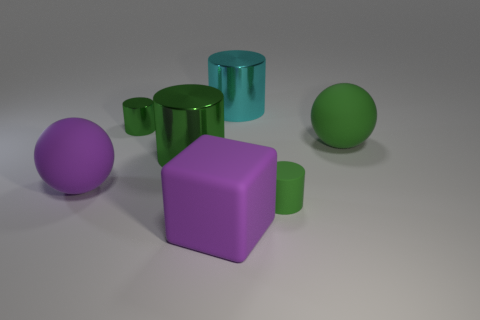Are there the same number of cyan objects that are on the left side of the big purple rubber sphere and large rubber cubes behind the large cube?
Provide a short and direct response. Yes. There is a ball left of the tiny shiny cylinder; is there a big purple rubber sphere in front of it?
Give a very brief answer. No. What shape is the small green thing that is the same material as the green sphere?
Make the answer very short. Cylinder. Are there any other things of the same color as the tiny matte cylinder?
Your response must be concise. Yes. What material is the small object that is in front of the small green cylinder that is on the left side of the rubber cylinder made of?
Offer a terse response. Rubber. Are there any big blue objects that have the same shape as the large green shiny thing?
Your response must be concise. No. What number of other objects are the same shape as the large cyan shiny thing?
Keep it short and to the point. 3. The object that is both right of the large cyan metallic object and to the left of the big green rubber thing has what shape?
Offer a very short reply. Cylinder. What size is the purple rubber block that is right of the small green shiny cylinder?
Make the answer very short. Large. Do the green rubber cylinder and the purple rubber sphere have the same size?
Your answer should be very brief. No. 